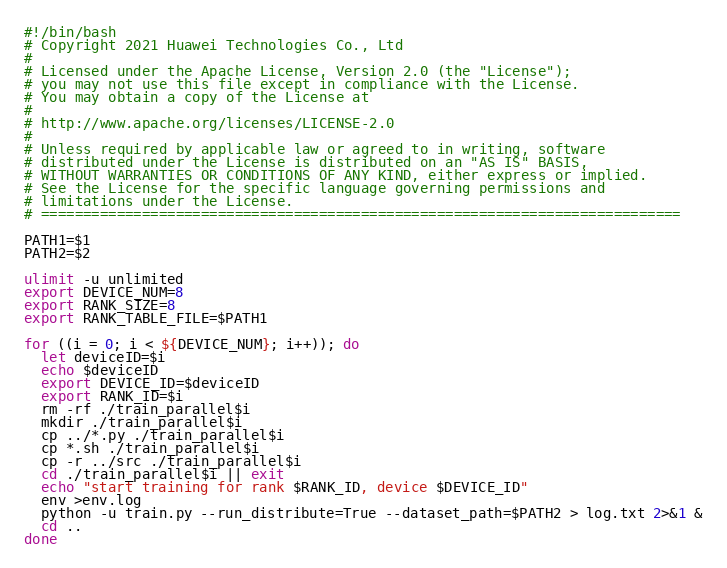Convert code to text. <code><loc_0><loc_0><loc_500><loc_500><_Bash_>#!/bin/bash
# Copyright 2021 Huawei Technologies Co., Ltd
#
# Licensed under the Apache License, Version 2.0 (the "License");
# you may not use this file except in compliance with the License.
# You may obtain a copy of the License at
#
# http://www.apache.org/licenses/LICENSE-2.0
#
# Unless required by applicable law or agreed to in writing, software
# distributed under the License is distributed on an "AS IS" BASIS,
# WITHOUT WARRANTIES OR CONDITIONS OF ANY KIND, either express or implied.
# See the License for the specific language governing permissions and
# limitations under the License.
# ============================================================================

PATH1=$1
PATH2=$2

ulimit -u unlimited
export DEVICE_NUM=8
export RANK_SIZE=8
export RANK_TABLE_FILE=$PATH1

for ((i = 0; i < ${DEVICE_NUM}; i++)); do
  let deviceID=$i
  echo $deviceID
  export DEVICE_ID=$deviceID
  export RANK_ID=$i
  rm -rf ./train_parallel$i
  mkdir ./train_parallel$i
  cp ../*.py ./train_parallel$i
  cp *.sh ./train_parallel$i
  cp -r ../src ./train_parallel$i
  cd ./train_parallel$i || exit
  echo "start training for rank $RANK_ID, device $DEVICE_ID"
  env >env.log
  python -u train.py --run_distribute=True --dataset_path=$PATH2 > log.txt 2>&1 &
  cd ..
done</code> 